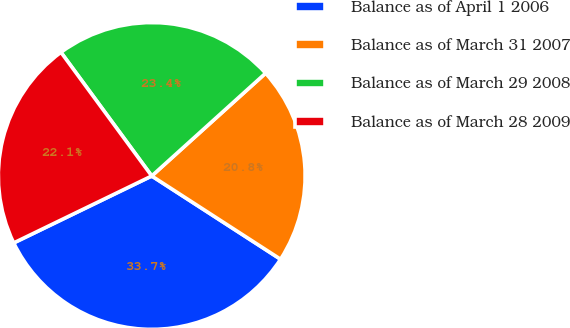<chart> <loc_0><loc_0><loc_500><loc_500><pie_chart><fcel>Balance as of April 1 2006<fcel>Balance as of March 31 2007<fcel>Balance as of March 29 2008<fcel>Balance as of March 28 2009<nl><fcel>33.68%<fcel>20.82%<fcel>23.39%<fcel>22.11%<nl></chart> 